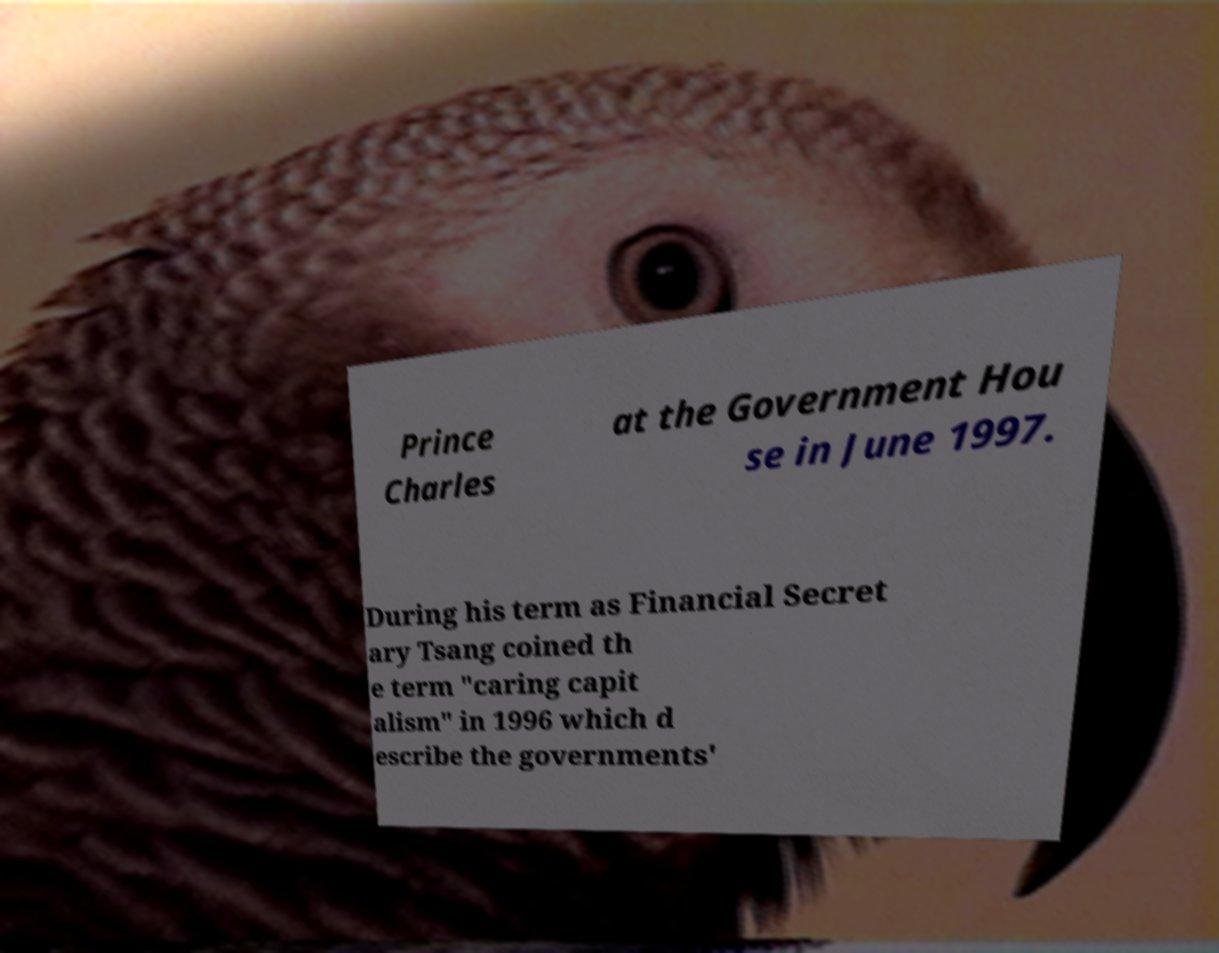Could you assist in decoding the text presented in this image and type it out clearly? Prince Charles at the Government Hou se in June 1997. During his term as Financial Secret ary Tsang coined th e term "caring capit alism" in 1996 which d escribe the governments' 